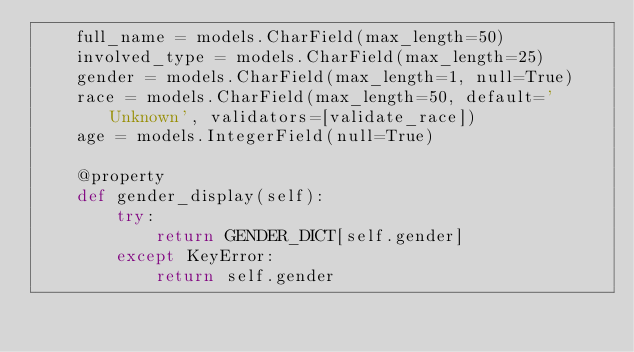<code> <loc_0><loc_0><loc_500><loc_500><_Python_>    full_name = models.CharField(max_length=50)
    involved_type = models.CharField(max_length=25)
    gender = models.CharField(max_length=1, null=True)
    race = models.CharField(max_length=50, default='Unknown', validators=[validate_race])
    age = models.IntegerField(null=True)

    @property
    def gender_display(self):
        try:
            return GENDER_DICT[self.gender]
        except KeyError:
            return self.gender
</code> 